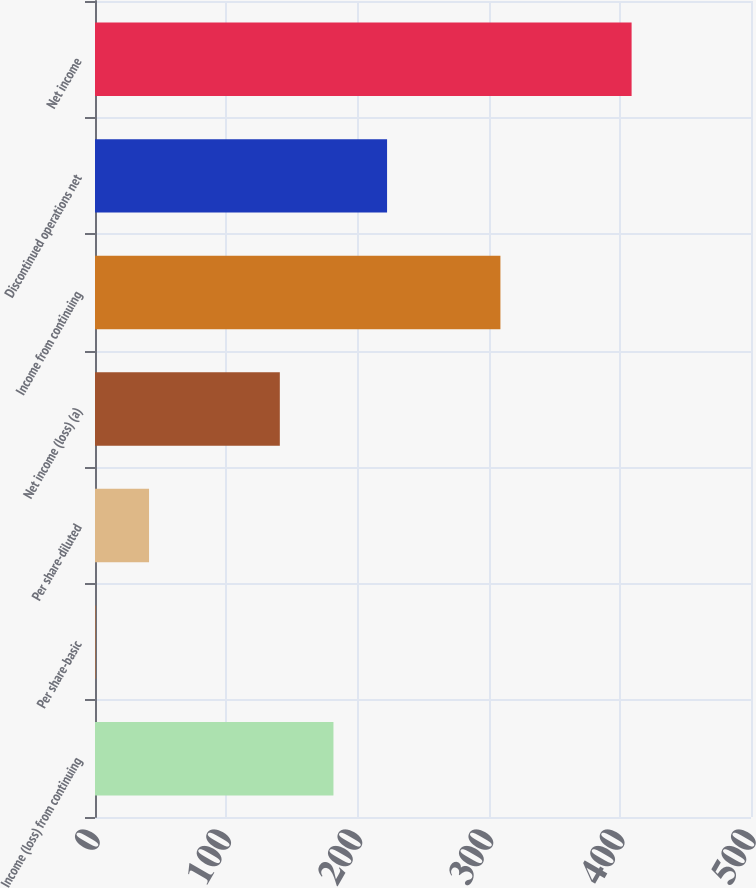<chart> <loc_0><loc_0><loc_500><loc_500><bar_chart><fcel>Income (loss) from continuing<fcel>Per share-basic<fcel>Per share-diluted<fcel>Net income (loss) (a)<fcel>Income from continuing<fcel>Discontinued operations net<fcel>Net income<nl><fcel>181.74<fcel>0.33<fcel>41.2<fcel>140.87<fcel>309<fcel>222.61<fcel>409<nl></chart> 